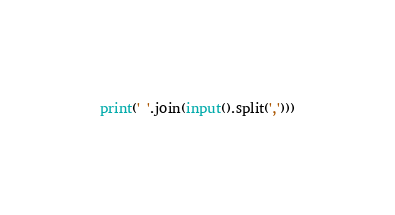<code> <loc_0><loc_0><loc_500><loc_500><_Python_>print(' '.join(input().split(',')))</code> 